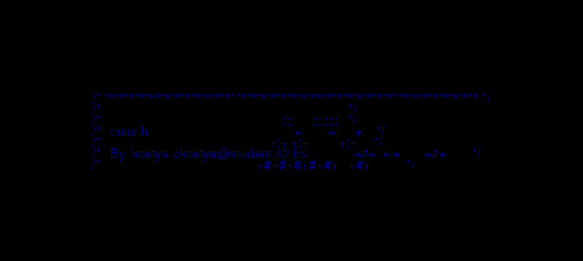Convert code to text. <code><loc_0><loc_0><loc_500><loc_500><_C_>/* ************************************************************************** */
/*                                                                            */
/*                                                        :::      ::::::::   */
/*   color.h                                            :+:      :+:    :+:   */
/*                                                    +:+ +:+         +:+     */
/*   By: kostya <kostya@student.42.fr>              +#+  +:+       +#+        */
/*                                                +#+#+#+#+#+   +#+           */</code> 